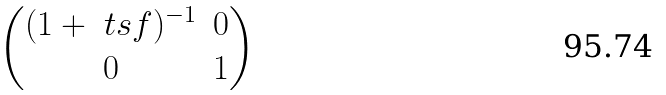<formula> <loc_0><loc_0><loc_500><loc_500>\begin{pmatrix} ( 1 + \ t s f ) ^ { - 1 } & 0 \\ 0 & 1 \end{pmatrix}</formula> 